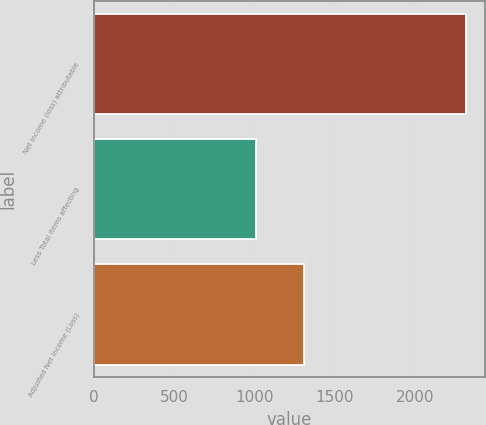Convert chart. <chart><loc_0><loc_0><loc_500><loc_500><bar_chart><fcel>Net income (loss) attributable<fcel>Less Total items affecting<fcel>Adjusted Net Income (Loss)<nl><fcel>2317<fcel>1009<fcel>1308<nl></chart> 